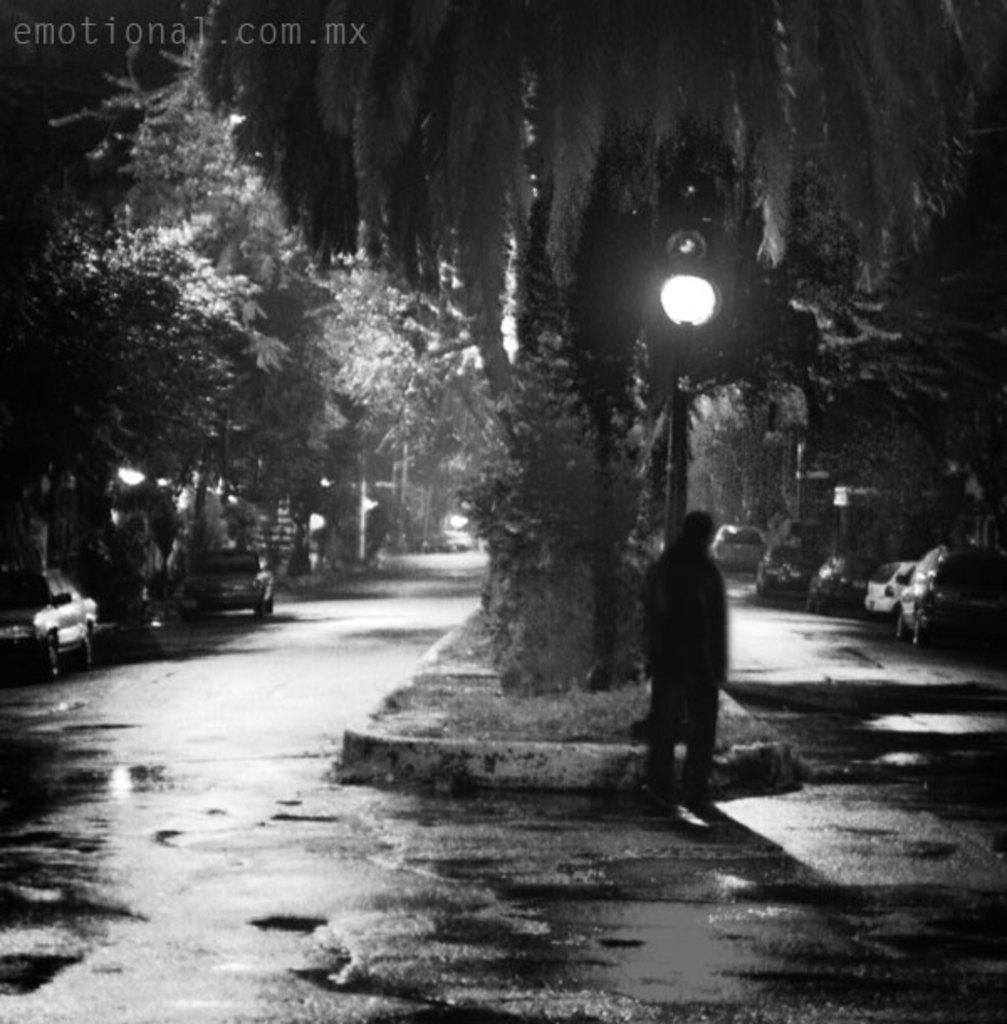What type of vehicles can be seen in the image? There are cars in the image. What other objects or features are present in the image? There are trees and a pole with a light in the image. Are there any people visible in the image? Yes, there is a person in the image. What type of copper material is being used to create the peace symbol in the image? There is no copper material or peace symbol present in the image. 